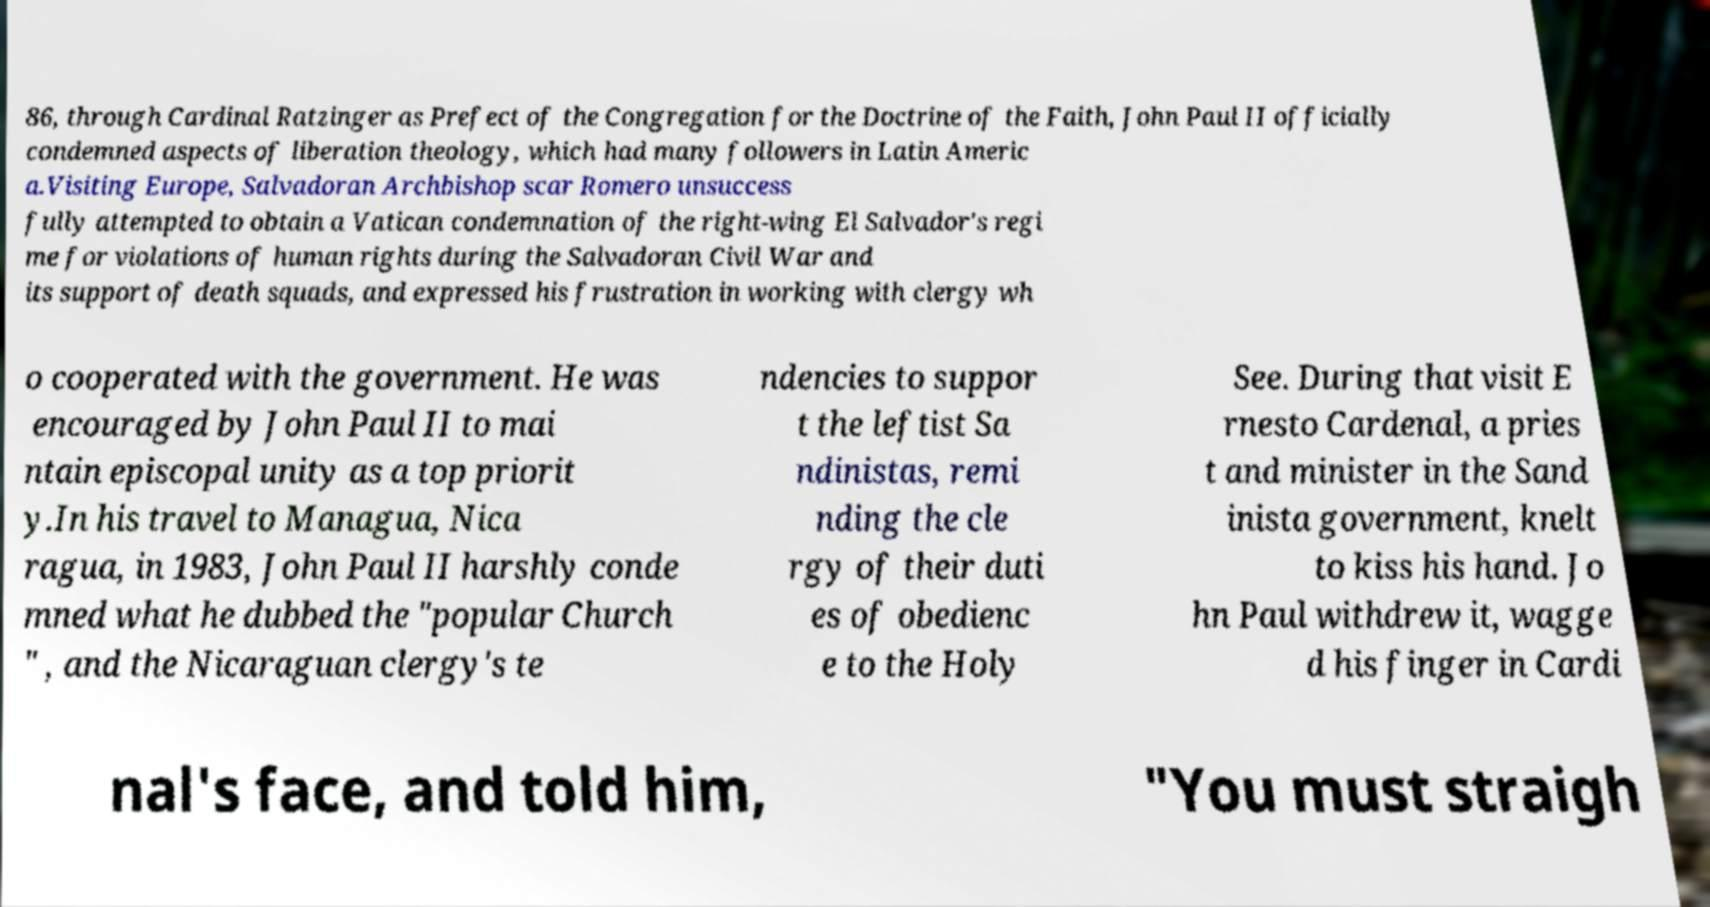For documentation purposes, I need the text within this image transcribed. Could you provide that? 86, through Cardinal Ratzinger as Prefect of the Congregation for the Doctrine of the Faith, John Paul II officially condemned aspects of liberation theology, which had many followers in Latin Americ a.Visiting Europe, Salvadoran Archbishop scar Romero unsuccess fully attempted to obtain a Vatican condemnation of the right-wing El Salvador's regi me for violations of human rights during the Salvadoran Civil War and its support of death squads, and expressed his frustration in working with clergy wh o cooperated with the government. He was encouraged by John Paul II to mai ntain episcopal unity as a top priorit y.In his travel to Managua, Nica ragua, in 1983, John Paul II harshly conde mned what he dubbed the "popular Church " , and the Nicaraguan clergy's te ndencies to suppor t the leftist Sa ndinistas, remi nding the cle rgy of their duti es of obedienc e to the Holy See. During that visit E rnesto Cardenal, a pries t and minister in the Sand inista government, knelt to kiss his hand. Jo hn Paul withdrew it, wagge d his finger in Cardi nal's face, and told him, "You must straigh 